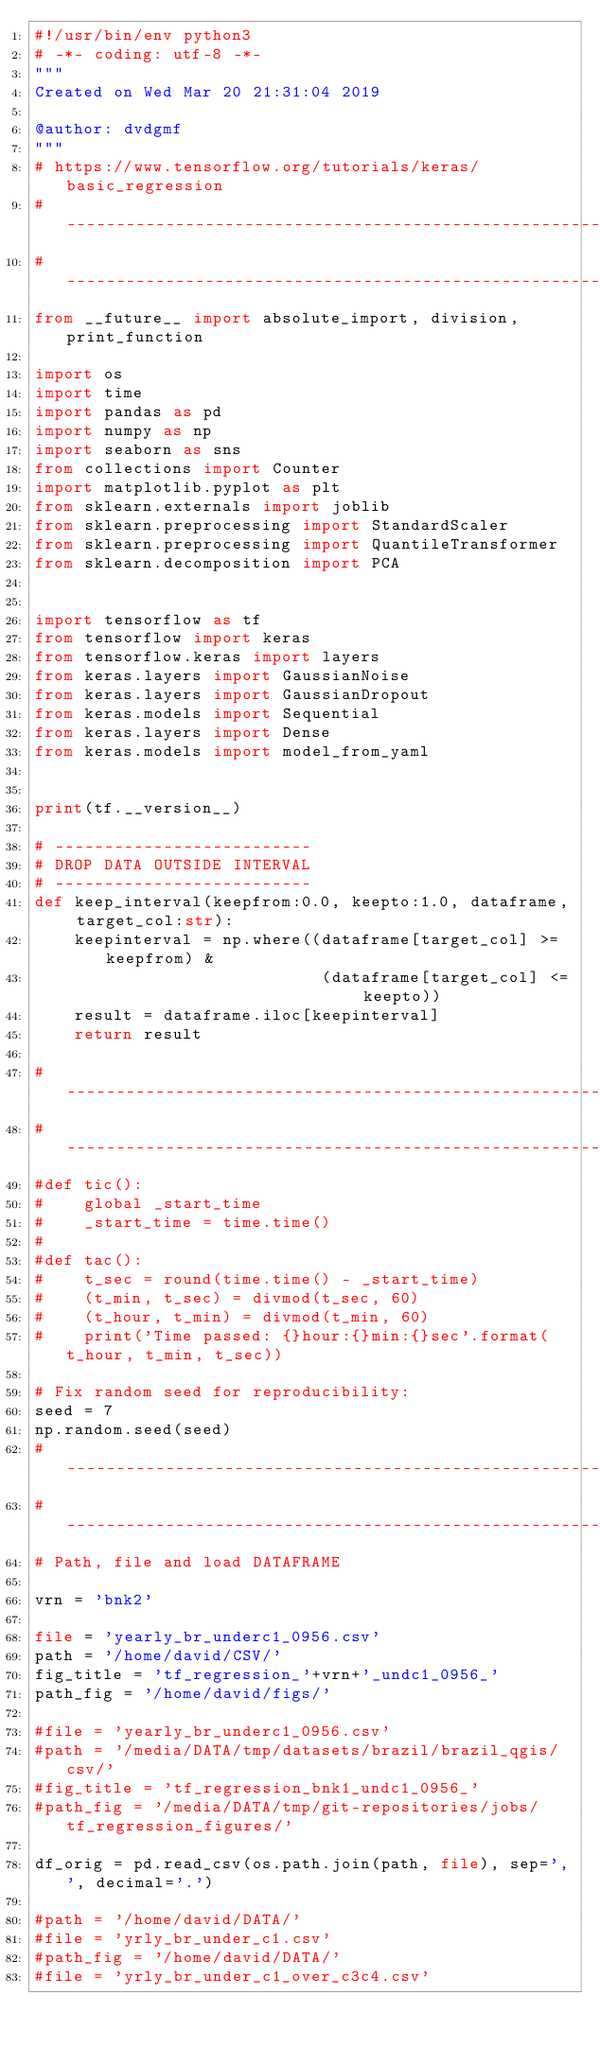Convert code to text. <code><loc_0><loc_0><loc_500><loc_500><_Python_>#!/usr/bin/env python3
# -*- coding: utf-8 -*-
"""
Created on Wed Mar 20 21:31:04 2019

@author: dvdgmf
"""
# https://www.tensorflow.org/tutorials/keras/basic_regression
#------------------------------------------------------------------------------
#------------------------------------------------------------------------------
from __future__ import absolute_import, division, print_function

import os
import time
import pandas as pd
import numpy as np
import seaborn as sns
from collections import Counter
import matplotlib.pyplot as plt
from sklearn.externals import joblib
from sklearn.preprocessing import StandardScaler
from sklearn.preprocessing import QuantileTransformer
from sklearn.decomposition import PCA


import tensorflow as tf
from tensorflow import keras
from tensorflow.keras import layers
from keras.layers import GaussianNoise
from keras.layers import GaussianDropout
from keras.models import Sequential
from keras.layers import Dense
from keras.models import model_from_yaml


print(tf.__version__)

# --------------------------
# DROP DATA OUTSIDE INTERVAL
# --------------------------
def keep_interval(keepfrom:0.0, keepto:1.0, dataframe, target_col:str):
    keepinterval = np.where((dataframe[target_col] >= keepfrom) &
                             (dataframe[target_col] <= keepto))
    result = dataframe.iloc[keepinterval]    
    return result

#------------------------------------------------------------------------------
#------------------------------------------------------------------------------
#def tic():
#    global _start_time
#    _start_time = time.time()
#
#def tac():
#    t_sec = round(time.time() - _start_time)
#    (t_min, t_sec) = divmod(t_sec, 60)
#    (t_hour, t_min) = divmod(t_min, 60)
#    print('Time passed: {}hour:{}min:{}sec'.format(t_hour, t_min, t_sec))
    
# Fix random seed for reproducibility:
seed = 7
np.random.seed(seed)
#------------------------------------------------------------------------------
#------------------------------------------------------------------------------
# Path, file and load DATAFRAME

vrn = 'bnk2'

file = 'yearly_br_underc1_0956.csv'
path = '/home/david/CSV/'
fig_title = 'tf_regression_'+vrn+'_undc1_0956_'
path_fig = '/home/david/figs/'

#file = 'yearly_br_underc1_0956.csv'
#path = '/media/DATA/tmp/datasets/brazil/brazil_qgis/csv/'
#fig_title = 'tf_regression_bnk1_undc1_0956_'
#path_fig = '/media/DATA/tmp/git-repositories/jobs/tf_regression_figures/'

df_orig = pd.read_csv(os.path.join(path, file), sep=',', decimal='.')

#path = '/home/david/DATA/'
#file = 'yrly_br_under_c1.csv'
#path_fig = '/home/david/DATA/'
#file = 'yrly_br_under_c1_over_c3c4.csv'</code> 